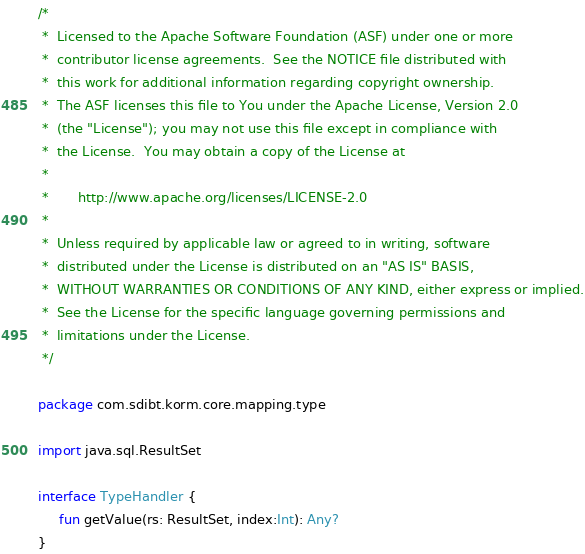<code> <loc_0><loc_0><loc_500><loc_500><_Kotlin_>/*
 *  Licensed to the Apache Software Foundation (ASF) under one or more
 *  contributor license agreements.  See the NOTICE file distributed with
 *  this work for additional information regarding copyright ownership.
 *  The ASF licenses this file to You under the Apache License, Version 2.0
 *  (the "License"); you may not use this file except in compliance with
 *  the License.  You may obtain a copy of the License at
 *
 *       http://www.apache.org/licenses/LICENSE-2.0
 *
 *  Unless required by applicable law or agreed to in writing, software
 *  distributed under the License is distributed on an "AS IS" BASIS,
 *  WITHOUT WARRANTIES OR CONDITIONS OF ANY KIND, either express or implied.
 *  See the License for the specific language governing permissions and
 *  limitations under the License.
 */

package com.sdibt.korm.core.mapping.type

import java.sql.ResultSet

interface TypeHandler {
	 fun getValue(rs: ResultSet, index:Int): Any?
}
</code> 